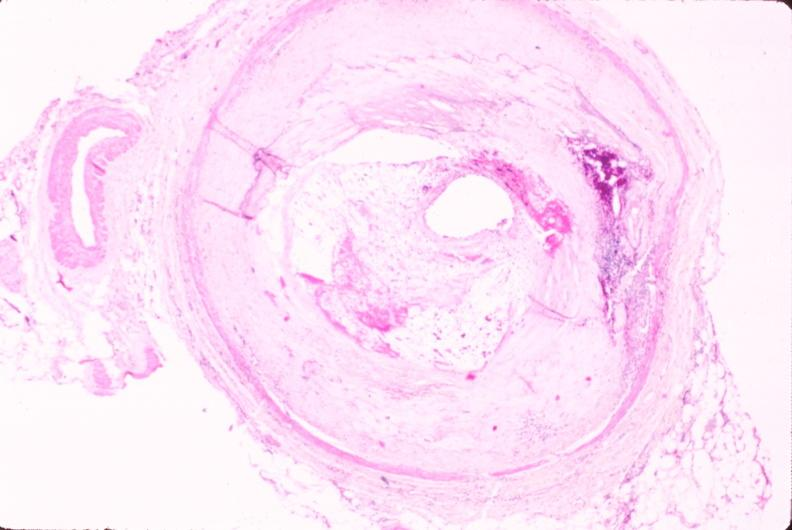s vasculature present?
Answer the question using a single word or phrase. Yes 